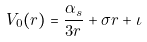<formula> <loc_0><loc_0><loc_500><loc_500>V _ { 0 } ( r ) = \frac { \alpha _ { s } } { 3 r } + \sigma r + \iota</formula> 